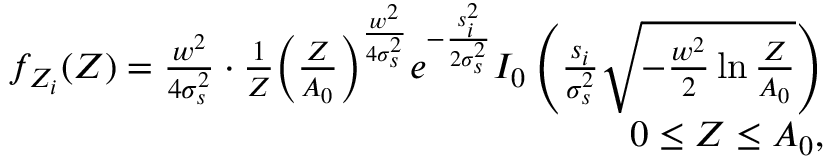Convert formula to latex. <formula><loc_0><loc_0><loc_500><loc_500>\begin{array} { r } { f _ { Z _ { i } } ( Z ) = \frac { w ^ { 2 } } { 4 \sigma _ { s } ^ { 2 } } \cdot \frac { 1 } { Z } \left ( \frac { Z } { A _ { 0 } } \right ) ^ { \frac { w ^ { 2 } } { 4 \sigma _ { s } ^ { 2 } } } e ^ { - \frac { s _ { i } ^ { 2 } } { 2 \sigma _ { s } ^ { 2 } } } I _ { 0 } \left ( \frac { s _ { i } } { \sigma _ { s } ^ { 2 } } \sqrt { - \frac { w ^ { 2 } } { 2 } \ln \frac { Z } { A _ { 0 } } } \right ) } \\ { 0 \leq { Z } \leq { A _ { 0 } } , } \end{array}</formula> 